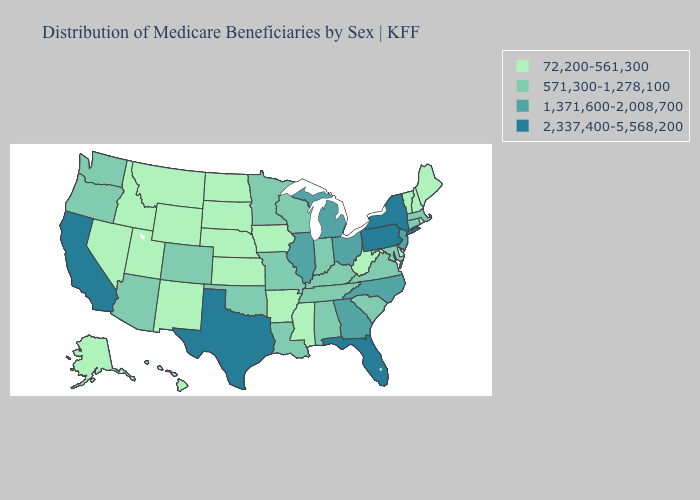Does the map have missing data?
Concise answer only. No. Name the states that have a value in the range 571,300-1,278,100?
Short answer required. Alabama, Arizona, Colorado, Connecticut, Indiana, Kentucky, Louisiana, Maryland, Massachusetts, Minnesota, Missouri, Oklahoma, Oregon, South Carolina, Tennessee, Virginia, Washington, Wisconsin. Name the states that have a value in the range 2,337,400-5,568,200?
Give a very brief answer. California, Florida, New York, Pennsylvania, Texas. What is the lowest value in the USA?
Short answer required. 72,200-561,300. Name the states that have a value in the range 72,200-561,300?
Write a very short answer. Alaska, Arkansas, Delaware, Hawaii, Idaho, Iowa, Kansas, Maine, Mississippi, Montana, Nebraska, Nevada, New Hampshire, New Mexico, North Dakota, Rhode Island, South Dakota, Utah, Vermont, West Virginia, Wyoming. Name the states that have a value in the range 2,337,400-5,568,200?
Answer briefly. California, Florida, New York, Pennsylvania, Texas. Name the states that have a value in the range 72,200-561,300?
Give a very brief answer. Alaska, Arkansas, Delaware, Hawaii, Idaho, Iowa, Kansas, Maine, Mississippi, Montana, Nebraska, Nevada, New Hampshire, New Mexico, North Dakota, Rhode Island, South Dakota, Utah, Vermont, West Virginia, Wyoming. What is the highest value in states that border Michigan?
Give a very brief answer. 1,371,600-2,008,700. Does Connecticut have a higher value than Nevada?
Quick response, please. Yes. What is the value of Louisiana?
Short answer required. 571,300-1,278,100. Name the states that have a value in the range 1,371,600-2,008,700?
Keep it brief. Georgia, Illinois, Michigan, New Jersey, North Carolina, Ohio. Name the states that have a value in the range 1,371,600-2,008,700?
Keep it brief. Georgia, Illinois, Michigan, New Jersey, North Carolina, Ohio. Name the states that have a value in the range 72,200-561,300?
Concise answer only. Alaska, Arkansas, Delaware, Hawaii, Idaho, Iowa, Kansas, Maine, Mississippi, Montana, Nebraska, Nevada, New Hampshire, New Mexico, North Dakota, Rhode Island, South Dakota, Utah, Vermont, West Virginia, Wyoming. What is the value of California?
Quick response, please. 2,337,400-5,568,200. What is the value of New Mexico?
Write a very short answer. 72,200-561,300. 